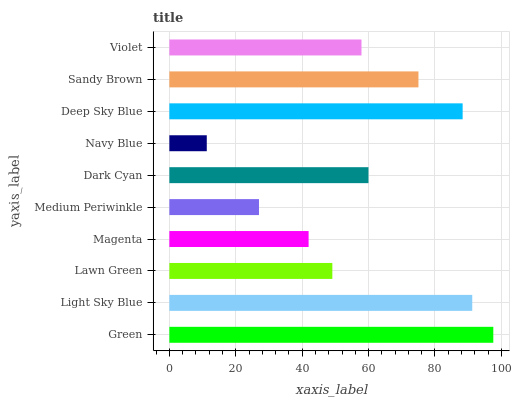Is Navy Blue the minimum?
Answer yes or no. Yes. Is Green the maximum?
Answer yes or no. Yes. Is Light Sky Blue the minimum?
Answer yes or no. No. Is Light Sky Blue the maximum?
Answer yes or no. No. Is Green greater than Light Sky Blue?
Answer yes or no. Yes. Is Light Sky Blue less than Green?
Answer yes or no. Yes. Is Light Sky Blue greater than Green?
Answer yes or no. No. Is Green less than Light Sky Blue?
Answer yes or no. No. Is Dark Cyan the high median?
Answer yes or no. Yes. Is Violet the low median?
Answer yes or no. Yes. Is Light Sky Blue the high median?
Answer yes or no. No. Is Magenta the low median?
Answer yes or no. No. 